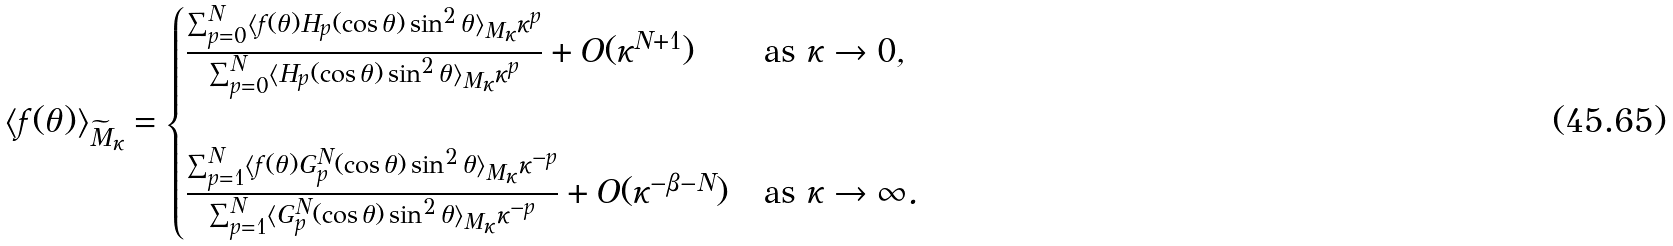<formula> <loc_0><loc_0><loc_500><loc_500>\langle f ( \theta ) \rangle _ { \widetilde { M } _ { \kappa } } = \begin{cases} \frac { \sum _ { p = 0 } ^ { N } \langle f ( \theta ) H _ { p } ( \cos \theta ) \sin ^ { 2 } \theta \rangle _ { M _ { \kappa } } \kappa ^ { p } } { \sum _ { p = 0 } ^ { N } \langle H _ { p } ( \cos \theta ) \sin ^ { 2 } \theta \rangle _ { M _ { \kappa } } \kappa ^ { p } } + O ( \kappa ^ { N + 1 } ) & \text {as } \kappa \to 0 , \\ & \\ \frac { \sum _ { p = 1 } ^ { N } \langle f ( \theta ) G _ { p } ^ { N } ( \cos \theta ) \sin ^ { 2 } \theta \rangle _ { M _ { \kappa } } \kappa ^ { - p } } { \sum _ { p = 1 } ^ { N } \langle G _ { p } ^ { N } ( \cos \theta ) \sin ^ { 2 } \theta \rangle _ { M _ { \kappa } } \kappa ^ { - p } } + O ( \kappa ^ { - \beta - N } ) & \text {as } \kappa \to \infty . \end{cases}</formula> 